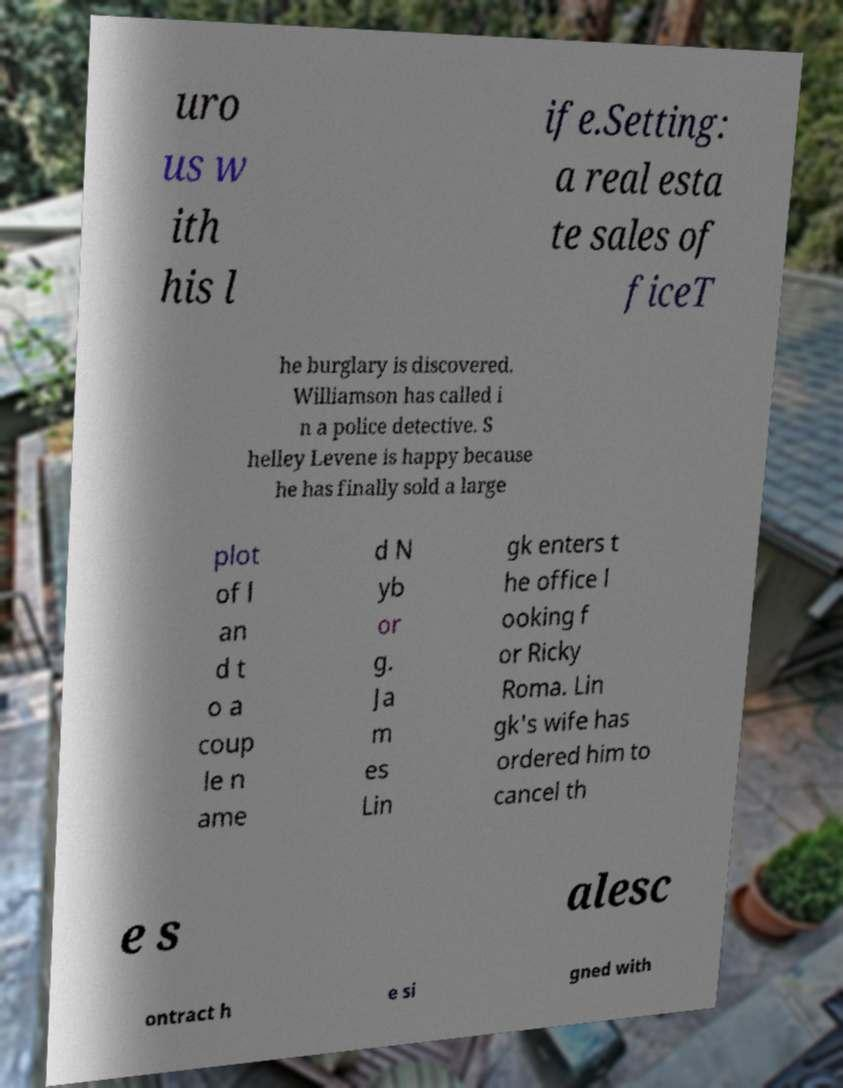Could you assist in decoding the text presented in this image and type it out clearly? uro us w ith his l ife.Setting: a real esta te sales of ficeT he burglary is discovered. Williamson has called i n a police detective. S helley Levene is happy because he has finally sold a large plot of l an d t o a coup le n ame d N yb or g. Ja m es Lin gk enters t he office l ooking f or Ricky Roma. Lin gk's wife has ordered him to cancel th e s alesc ontract h e si gned with 